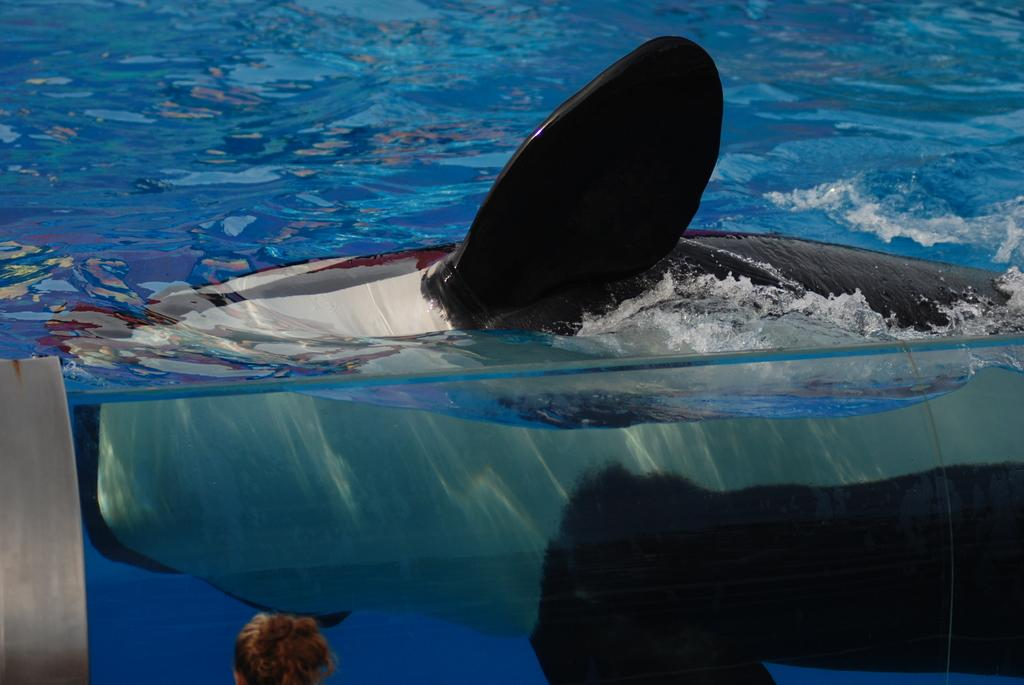What animal can be seen in the water in the image? There is a whale in the water in the image. Can you identify any human presence in the image? Yes, there is a person's head visible in the image. What type of ticket is required to stop the whale in the image? There is no mention of a ticket or stopping the whale in the image; it simply shows a whale in the water and a person's head. 